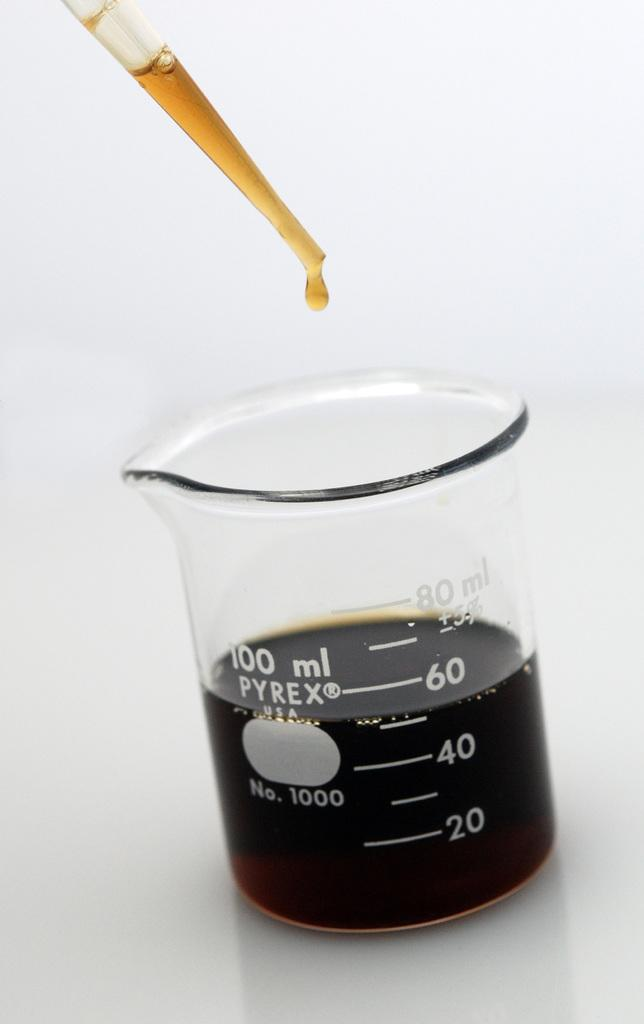<image>
Present a compact description of the photo's key features. A small Pyrex beaker that currently holds 50 ml of liquid 